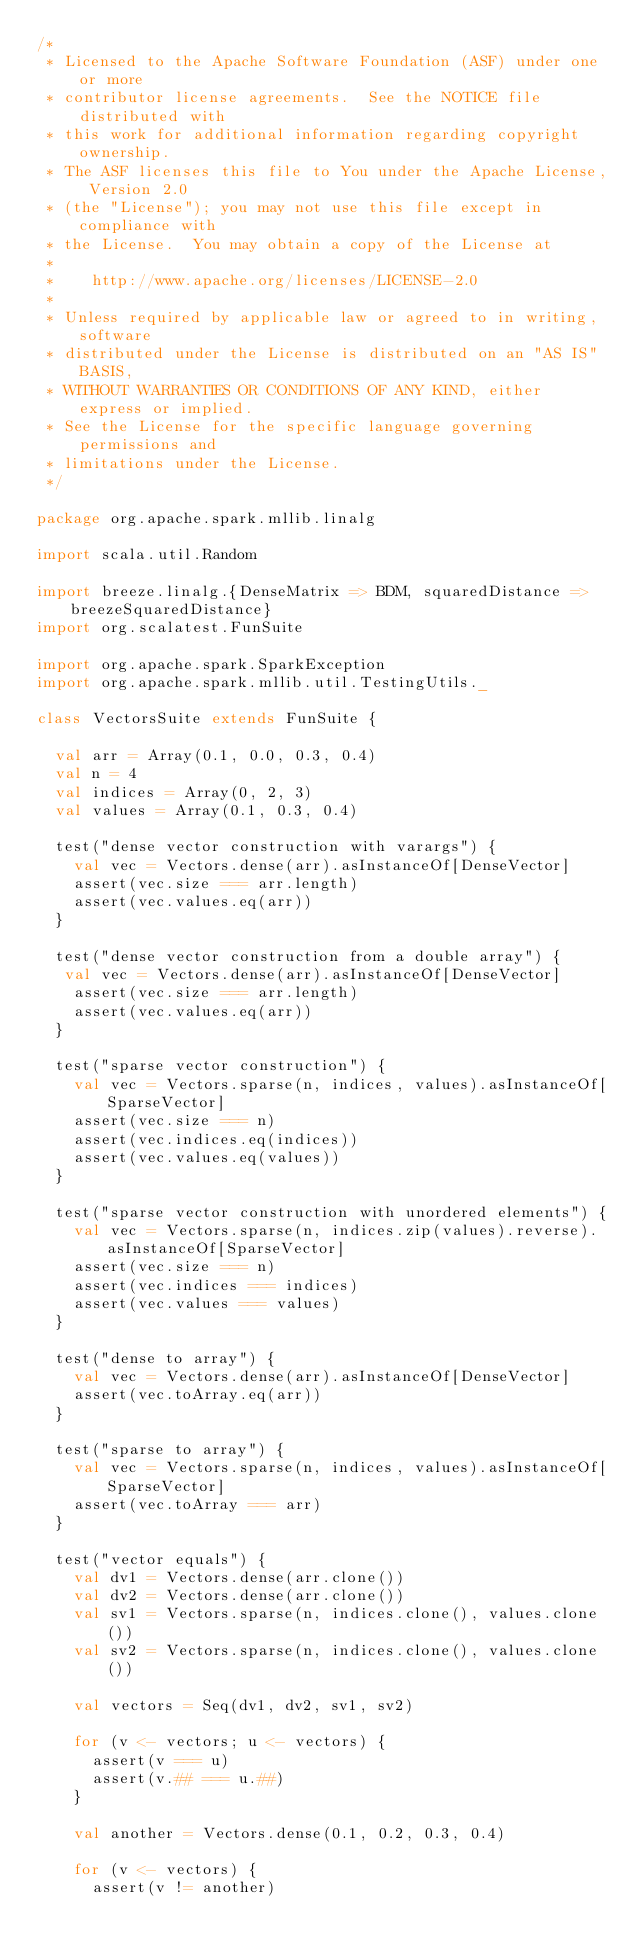Convert code to text. <code><loc_0><loc_0><loc_500><loc_500><_Scala_>/*
 * Licensed to the Apache Software Foundation (ASF) under one or more
 * contributor license agreements.  See the NOTICE file distributed with
 * this work for additional information regarding copyright ownership.
 * The ASF licenses this file to You under the Apache License, Version 2.0
 * (the "License"); you may not use this file except in compliance with
 * the License.  You may obtain a copy of the License at
 *
 *    http://www.apache.org/licenses/LICENSE-2.0
 *
 * Unless required by applicable law or agreed to in writing, software
 * distributed under the License is distributed on an "AS IS" BASIS,
 * WITHOUT WARRANTIES OR CONDITIONS OF ANY KIND, either express or implied.
 * See the License for the specific language governing permissions and
 * limitations under the License.
 */

package org.apache.spark.mllib.linalg

import scala.util.Random

import breeze.linalg.{DenseMatrix => BDM, squaredDistance => breezeSquaredDistance}
import org.scalatest.FunSuite

import org.apache.spark.SparkException
import org.apache.spark.mllib.util.TestingUtils._

class VectorsSuite extends FunSuite {

  val arr = Array(0.1, 0.0, 0.3, 0.4)
  val n = 4
  val indices = Array(0, 2, 3)
  val values = Array(0.1, 0.3, 0.4)

  test("dense vector construction with varargs") {
    val vec = Vectors.dense(arr).asInstanceOf[DenseVector]
    assert(vec.size === arr.length)
    assert(vec.values.eq(arr))
  }

  test("dense vector construction from a double array") {
   val vec = Vectors.dense(arr).asInstanceOf[DenseVector]
    assert(vec.size === arr.length)
    assert(vec.values.eq(arr))
  }

  test("sparse vector construction") {
    val vec = Vectors.sparse(n, indices, values).asInstanceOf[SparseVector]
    assert(vec.size === n)
    assert(vec.indices.eq(indices))
    assert(vec.values.eq(values))
  }

  test("sparse vector construction with unordered elements") {
    val vec = Vectors.sparse(n, indices.zip(values).reverse).asInstanceOf[SparseVector]
    assert(vec.size === n)
    assert(vec.indices === indices)
    assert(vec.values === values)
  }

  test("dense to array") {
    val vec = Vectors.dense(arr).asInstanceOf[DenseVector]
    assert(vec.toArray.eq(arr))
  }

  test("sparse to array") {
    val vec = Vectors.sparse(n, indices, values).asInstanceOf[SparseVector]
    assert(vec.toArray === arr)
  }

  test("vector equals") {
    val dv1 = Vectors.dense(arr.clone())
    val dv2 = Vectors.dense(arr.clone())
    val sv1 = Vectors.sparse(n, indices.clone(), values.clone())
    val sv2 = Vectors.sparse(n, indices.clone(), values.clone())

    val vectors = Seq(dv1, dv2, sv1, sv2)

    for (v <- vectors; u <- vectors) {
      assert(v === u)
      assert(v.## === u.##)
    }

    val another = Vectors.dense(0.1, 0.2, 0.3, 0.4)

    for (v <- vectors) {
      assert(v != another)</code> 